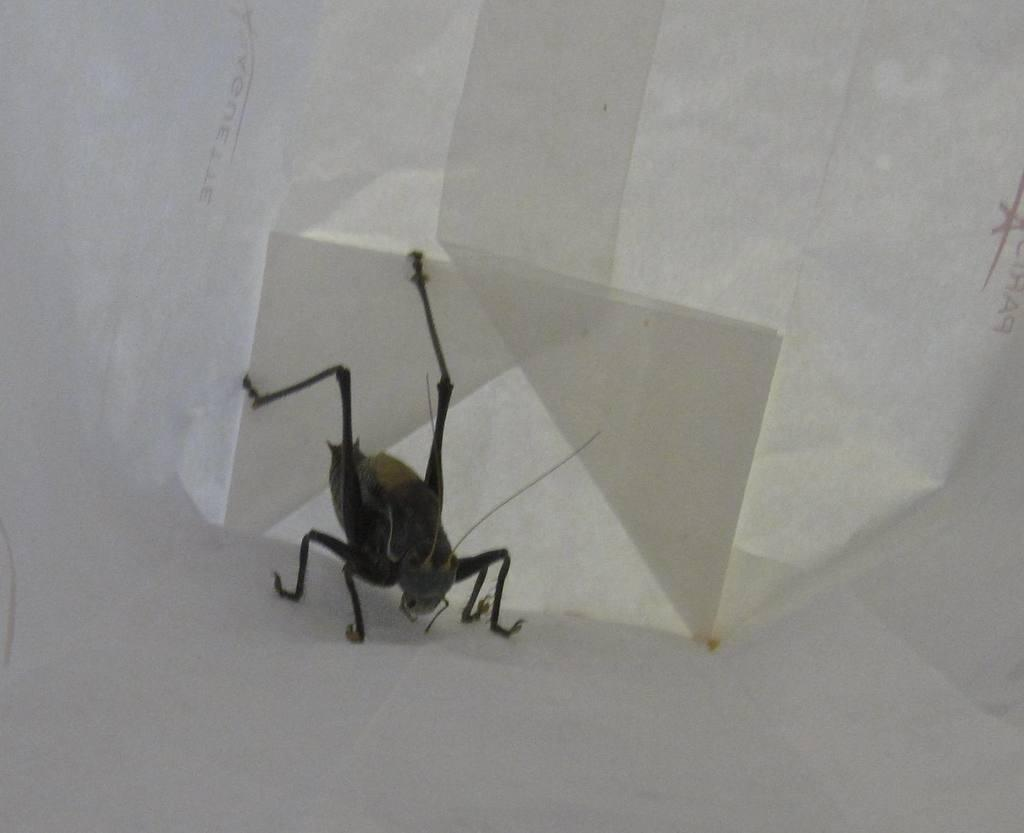What type of creature is present in the picture? There is an insect in the picture. What is the insect contained within? The insect is in a white box. Where is the insect and the box located in the picture? The insect and the box are in the center of the picture. What type of thrill can be seen experienced by the insect in the image? There is no indication of any thrill experienced by the insect in the image. What type of oil is used to maintain the insect in the image? There is no oil present in the image, nor is there any indication of the insect being maintained with oil. 